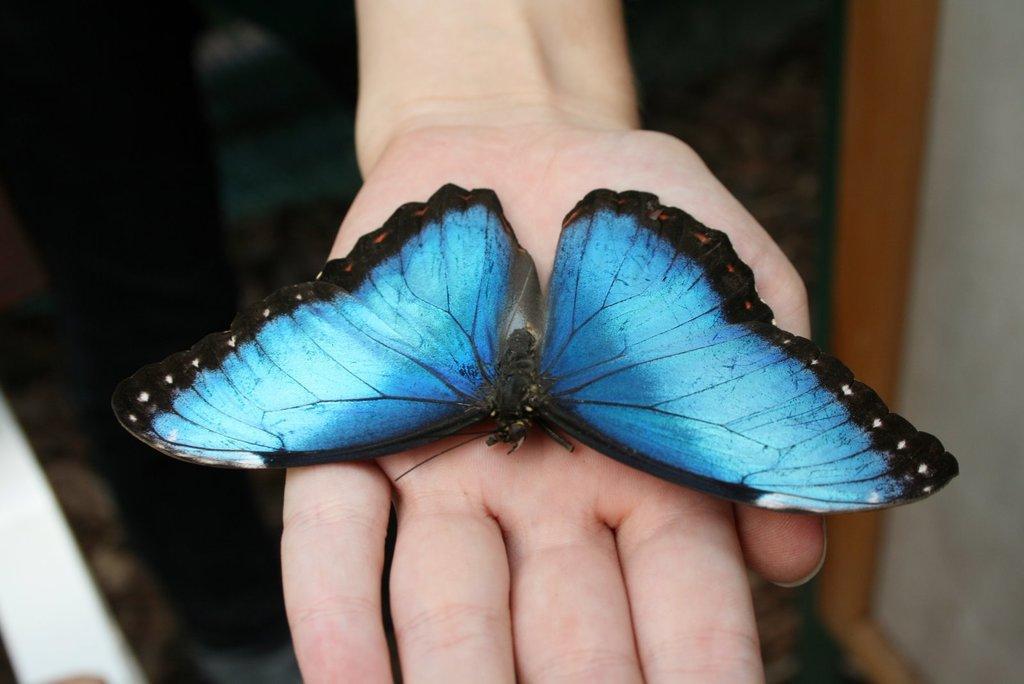Can you describe this image briefly? In this image I can see the butterfly on the person's hand and the butterfly is in blue and black color. 